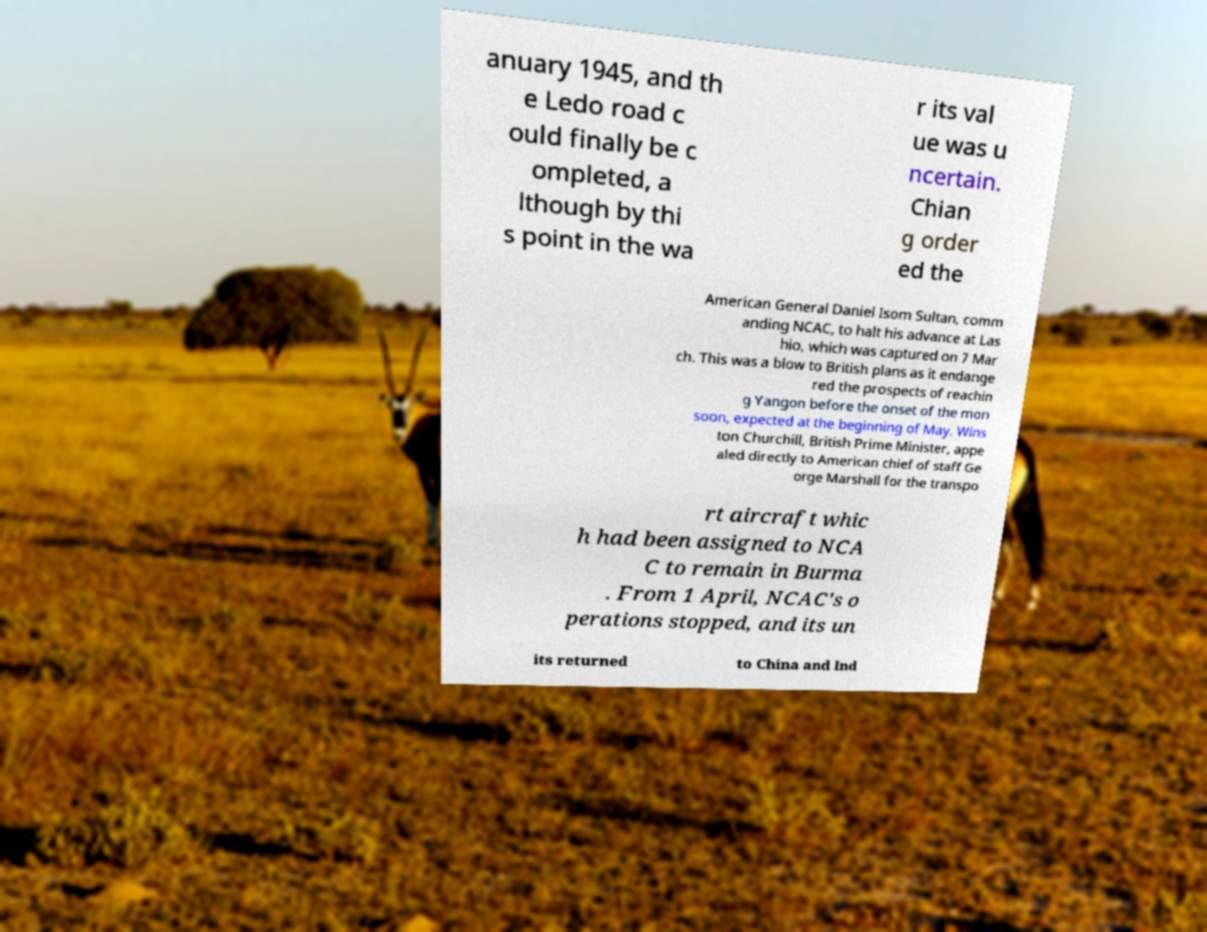For documentation purposes, I need the text within this image transcribed. Could you provide that? anuary 1945, and th e Ledo road c ould finally be c ompleted, a lthough by thi s point in the wa r its val ue was u ncertain. Chian g order ed the American General Daniel Isom Sultan, comm anding NCAC, to halt his advance at Las hio, which was captured on 7 Mar ch. This was a blow to British plans as it endange red the prospects of reachin g Yangon before the onset of the mon soon, expected at the beginning of May. Wins ton Churchill, British Prime Minister, appe aled directly to American chief of staff Ge orge Marshall for the transpo rt aircraft whic h had been assigned to NCA C to remain in Burma . From 1 April, NCAC's o perations stopped, and its un its returned to China and Ind 